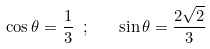<formula> <loc_0><loc_0><loc_500><loc_500>\cos \theta = \frac { 1 } { 3 } \ ; \quad \sin \theta = \frac { 2 \sqrt { 2 } } { 3 }</formula> 